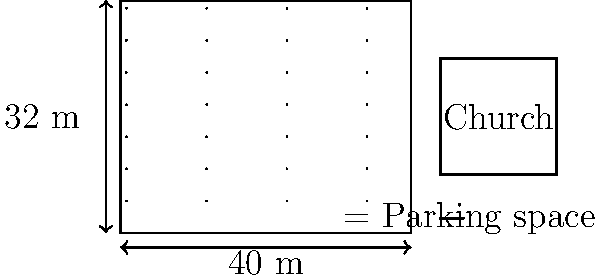As the pastor of a growing congregation in Shreveport, you're planning to expand the church's parking lot. The current lot measures 40 meters by 32 meters and uses a standard parking space size of 2.5 meters by 5 meters. If you want to increase the parking capacity by 25%, how many additional parking spaces do you need to add? To solve this problem, let's follow these steps:

1. Calculate the current number of parking spaces:
   - Lot dimensions: 40 m x 32 m
   - Space dimensions: 2.5 m x 5 m
   - Spaces along length: $40 \div 5 = 8$ spaces
   - Spaces along width: $32 \div 2.5 = 12.8$ spaces (round down to 12)
   - Total current spaces: $8 \times 12 = 96$ spaces

2. Calculate the desired number of parking spaces:
   - Increase by 25%: $96 \times 1.25 = 120$ spaces

3. Determine the number of additional spaces needed:
   - Additional spaces: $120 - 96 = 24$ spaces

Therefore, to increase the parking capacity by 25%, you need to add 24 parking spaces.
Answer: 24 additional parking spaces 